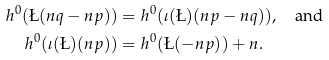Convert formula to latex. <formula><loc_0><loc_0><loc_500><loc_500>h ^ { 0 } ( \L ( n q - n p ) ) & = h ^ { 0 } ( \iota ( \L ) ( n p - n q ) ) , \quad \text {and} \\ h ^ { 0 } ( \iota ( \L ) ( n p ) ) & = h ^ { 0 } ( \L ( - n p ) ) + n .</formula> 